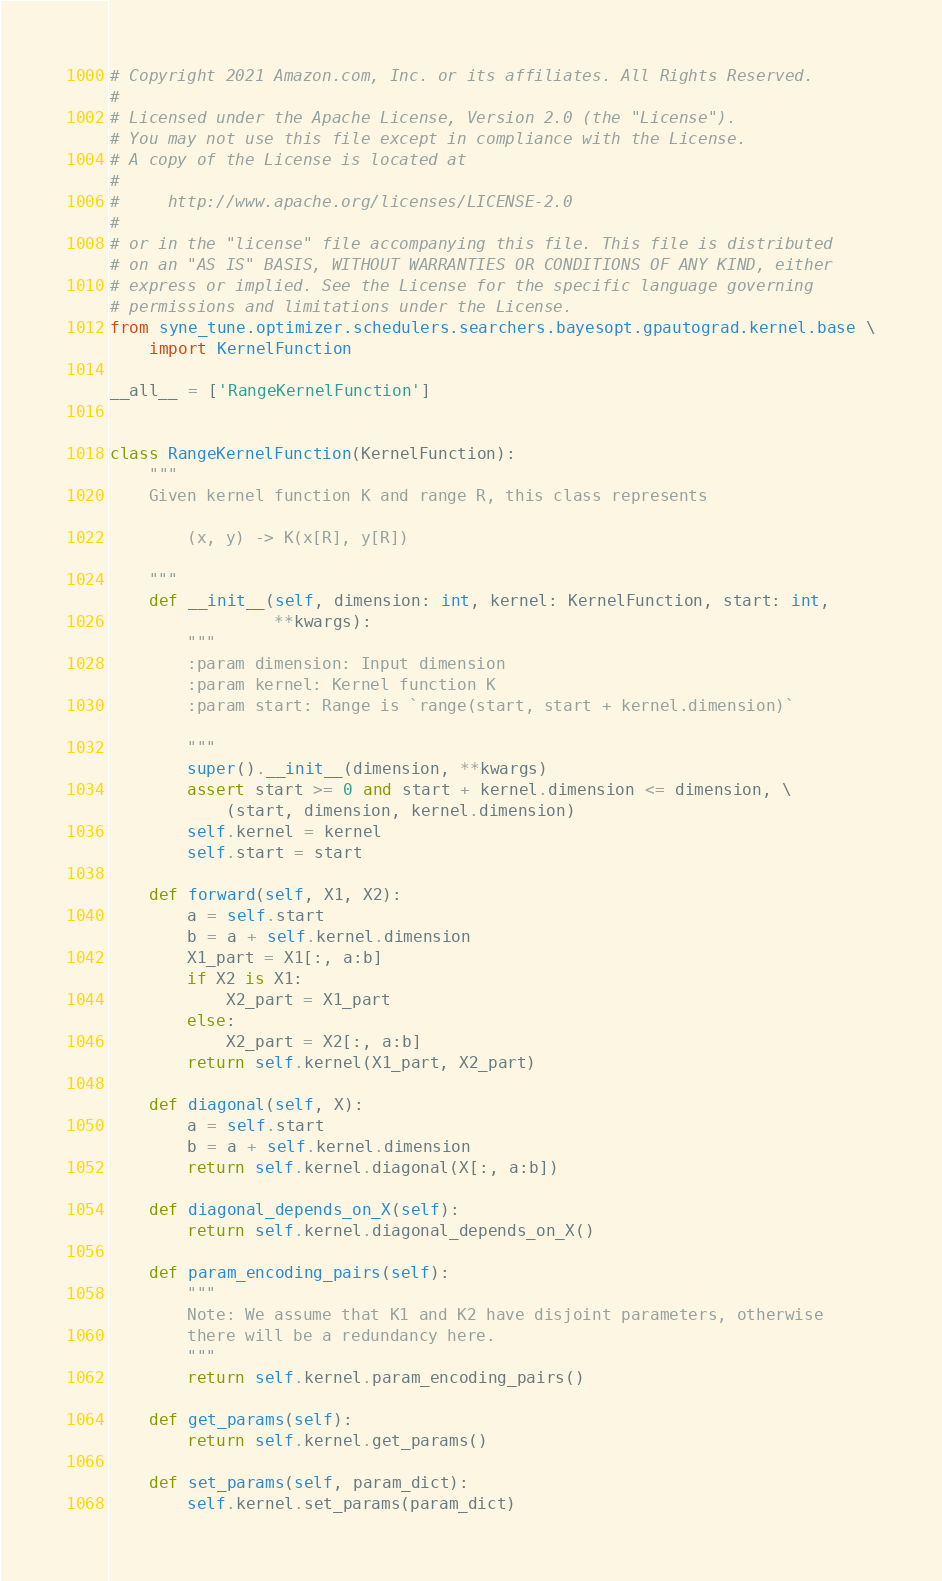Convert code to text. <code><loc_0><loc_0><loc_500><loc_500><_Python_># Copyright 2021 Amazon.com, Inc. or its affiliates. All Rights Reserved.
#
# Licensed under the Apache License, Version 2.0 (the "License").
# You may not use this file except in compliance with the License.
# A copy of the License is located at
#
#     http://www.apache.org/licenses/LICENSE-2.0
#
# or in the "license" file accompanying this file. This file is distributed
# on an "AS IS" BASIS, WITHOUT WARRANTIES OR CONDITIONS OF ANY KIND, either
# express or implied. See the License for the specific language governing
# permissions and limitations under the License.
from syne_tune.optimizer.schedulers.searchers.bayesopt.gpautograd.kernel.base \
    import KernelFunction

__all__ = ['RangeKernelFunction']


class RangeKernelFunction(KernelFunction):
    """
    Given kernel function K and range R, this class represents

        (x, y) -> K(x[R], y[R])

    """
    def __init__(self, dimension: int, kernel: KernelFunction, start: int,
                 **kwargs):
        """
        :param dimension: Input dimension
        :param kernel: Kernel function K
        :param start: Range is `range(start, start + kernel.dimension)`

        """
        super().__init__(dimension, **kwargs)
        assert start >= 0 and start + kernel.dimension <= dimension, \
            (start, dimension, kernel.dimension)
        self.kernel = kernel
        self.start = start

    def forward(self, X1, X2):
        a = self.start
        b = a + self.kernel.dimension
        X1_part = X1[:, a:b]
        if X2 is X1:
            X2_part = X1_part
        else:
            X2_part = X2[:, a:b]
        return self.kernel(X1_part, X2_part)

    def diagonal(self, X):
        a = self.start
        b = a + self.kernel.dimension
        return self.kernel.diagonal(X[:, a:b])

    def diagonal_depends_on_X(self):
        return self.kernel.diagonal_depends_on_X()

    def param_encoding_pairs(self):
        """
        Note: We assume that K1 and K2 have disjoint parameters, otherwise
        there will be a redundancy here.
        """
        return self.kernel.param_encoding_pairs()

    def get_params(self):
        return self.kernel.get_params()

    def set_params(self, param_dict):
        self.kernel.set_params(param_dict)
</code> 